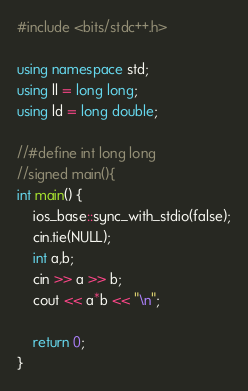<code> <loc_0><loc_0><loc_500><loc_500><_C++_>#include <bits/stdc++.h>

using namespace std;
using ll = long long;
using ld = long double;

//#define int long long
//signed main(){
int main() {
    ios_base::sync_with_stdio(false);
    cin.tie(NULL);
    int a,b;
    cin >> a >> b;
    cout << a*b << "\n";

    return 0;
}</code> 